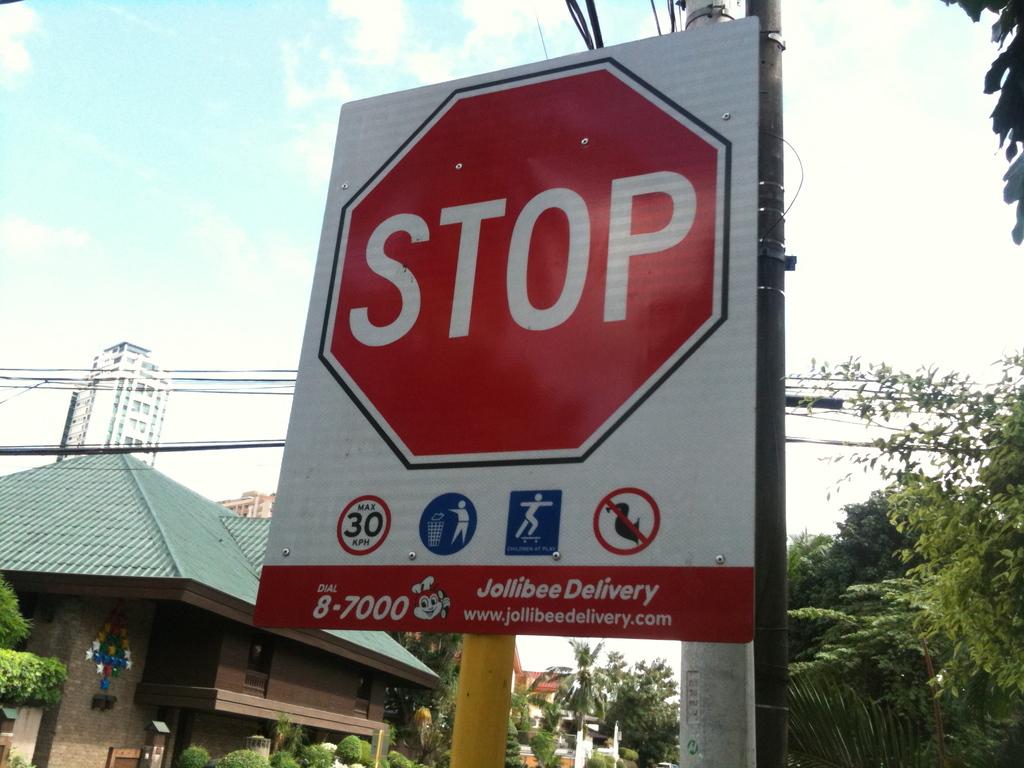What does this traffic sign say?
Your answer should be compact. Stop. 